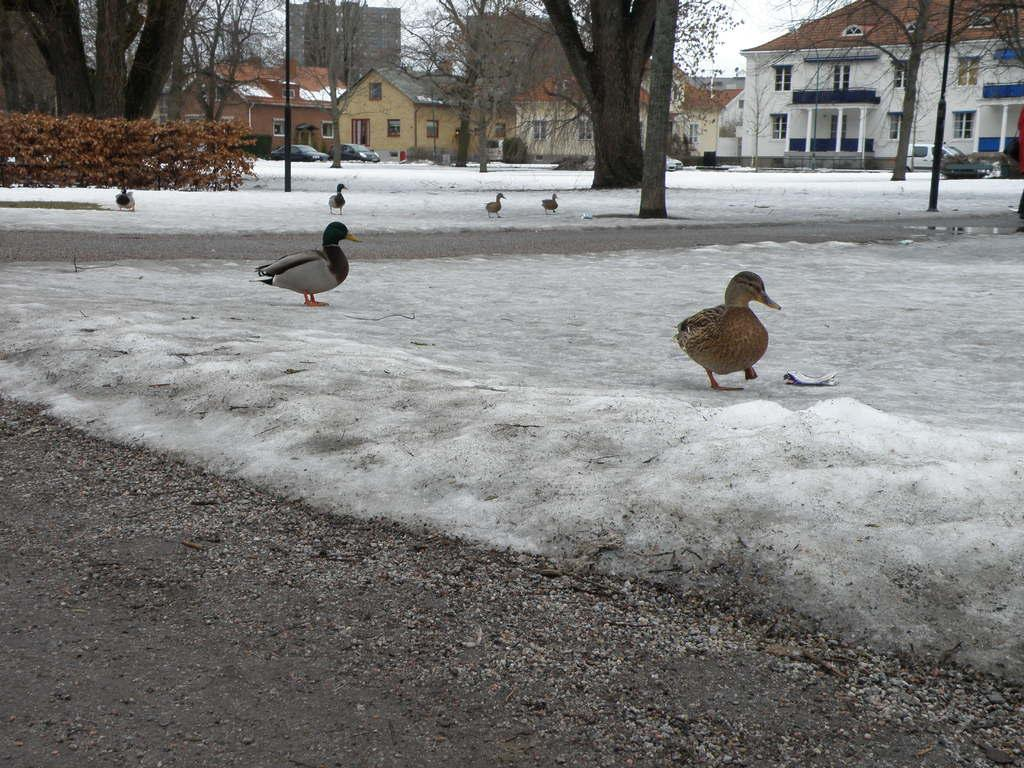What type of animals can be seen on the ground in the image? There are birds on the ground in the image. What type of natural vegetation is visible in the image? There are trees visible in the image. What type of man-made structures can be seen in the background of the image? There are buildings in the background of the image. What part of the natural environment is visible in the image? The sky is visible in the image. What type of pollution can be seen in the image? There is no pollution visible in the image. What type of vegetable is growing in the image? There is no vegetable present in the image. 